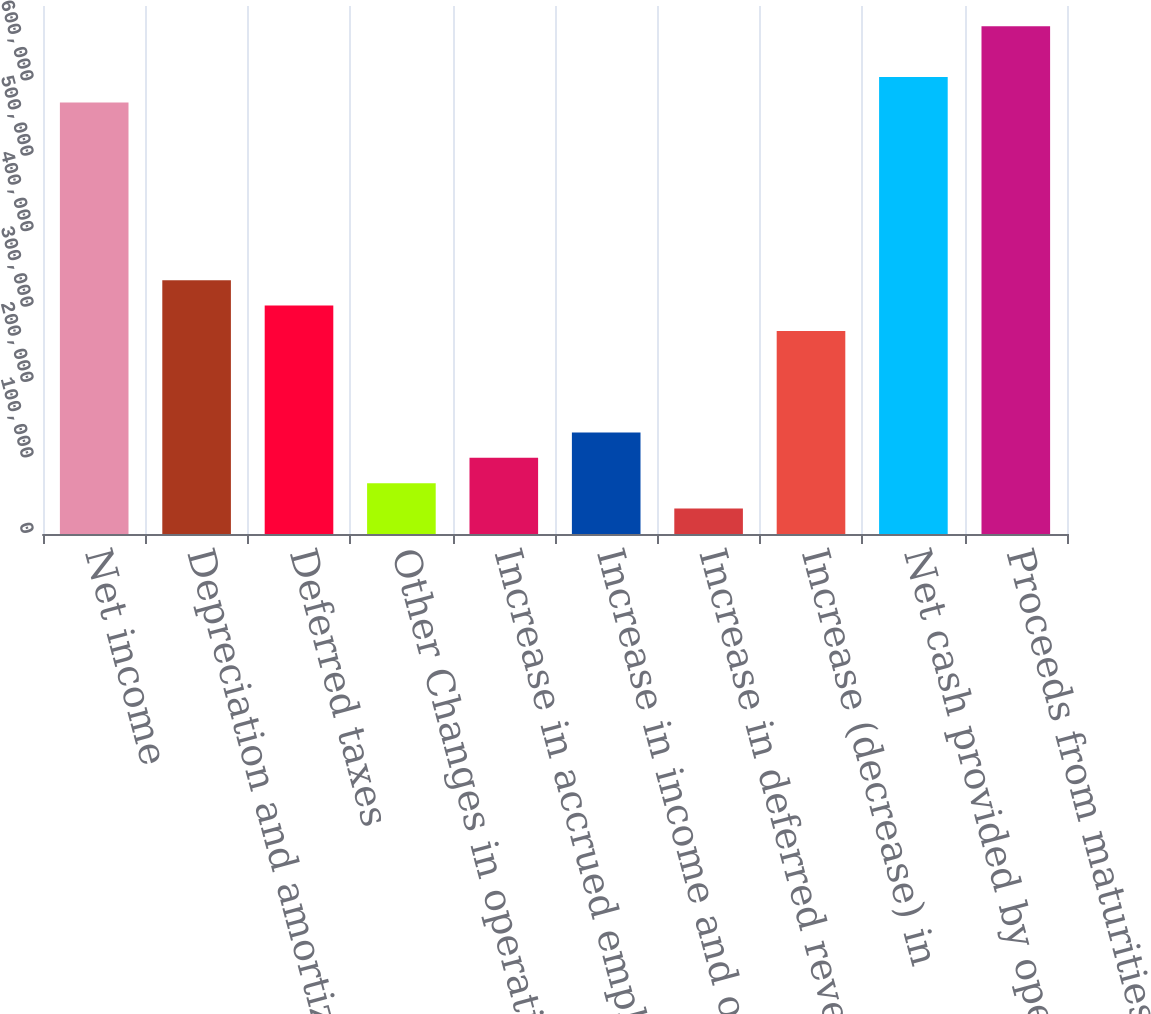Convert chart. <chart><loc_0><loc_0><loc_500><loc_500><bar_chart><fcel>Net income<fcel>Depreciation and amortization<fcel>Deferred taxes<fcel>Other Changes in operating<fcel>Increase in accrued employee<fcel>Increase in income and other<fcel>Increase in deferred revenue<fcel>Increase (decrease) in<fcel>Net cash provided by operating<fcel>Proceeds from maturities and<nl><fcel>572079<fcel>336533<fcel>302884<fcel>67337.8<fcel>100987<fcel>134637<fcel>33688.4<fcel>269234<fcel>605728<fcel>673027<nl></chart> 